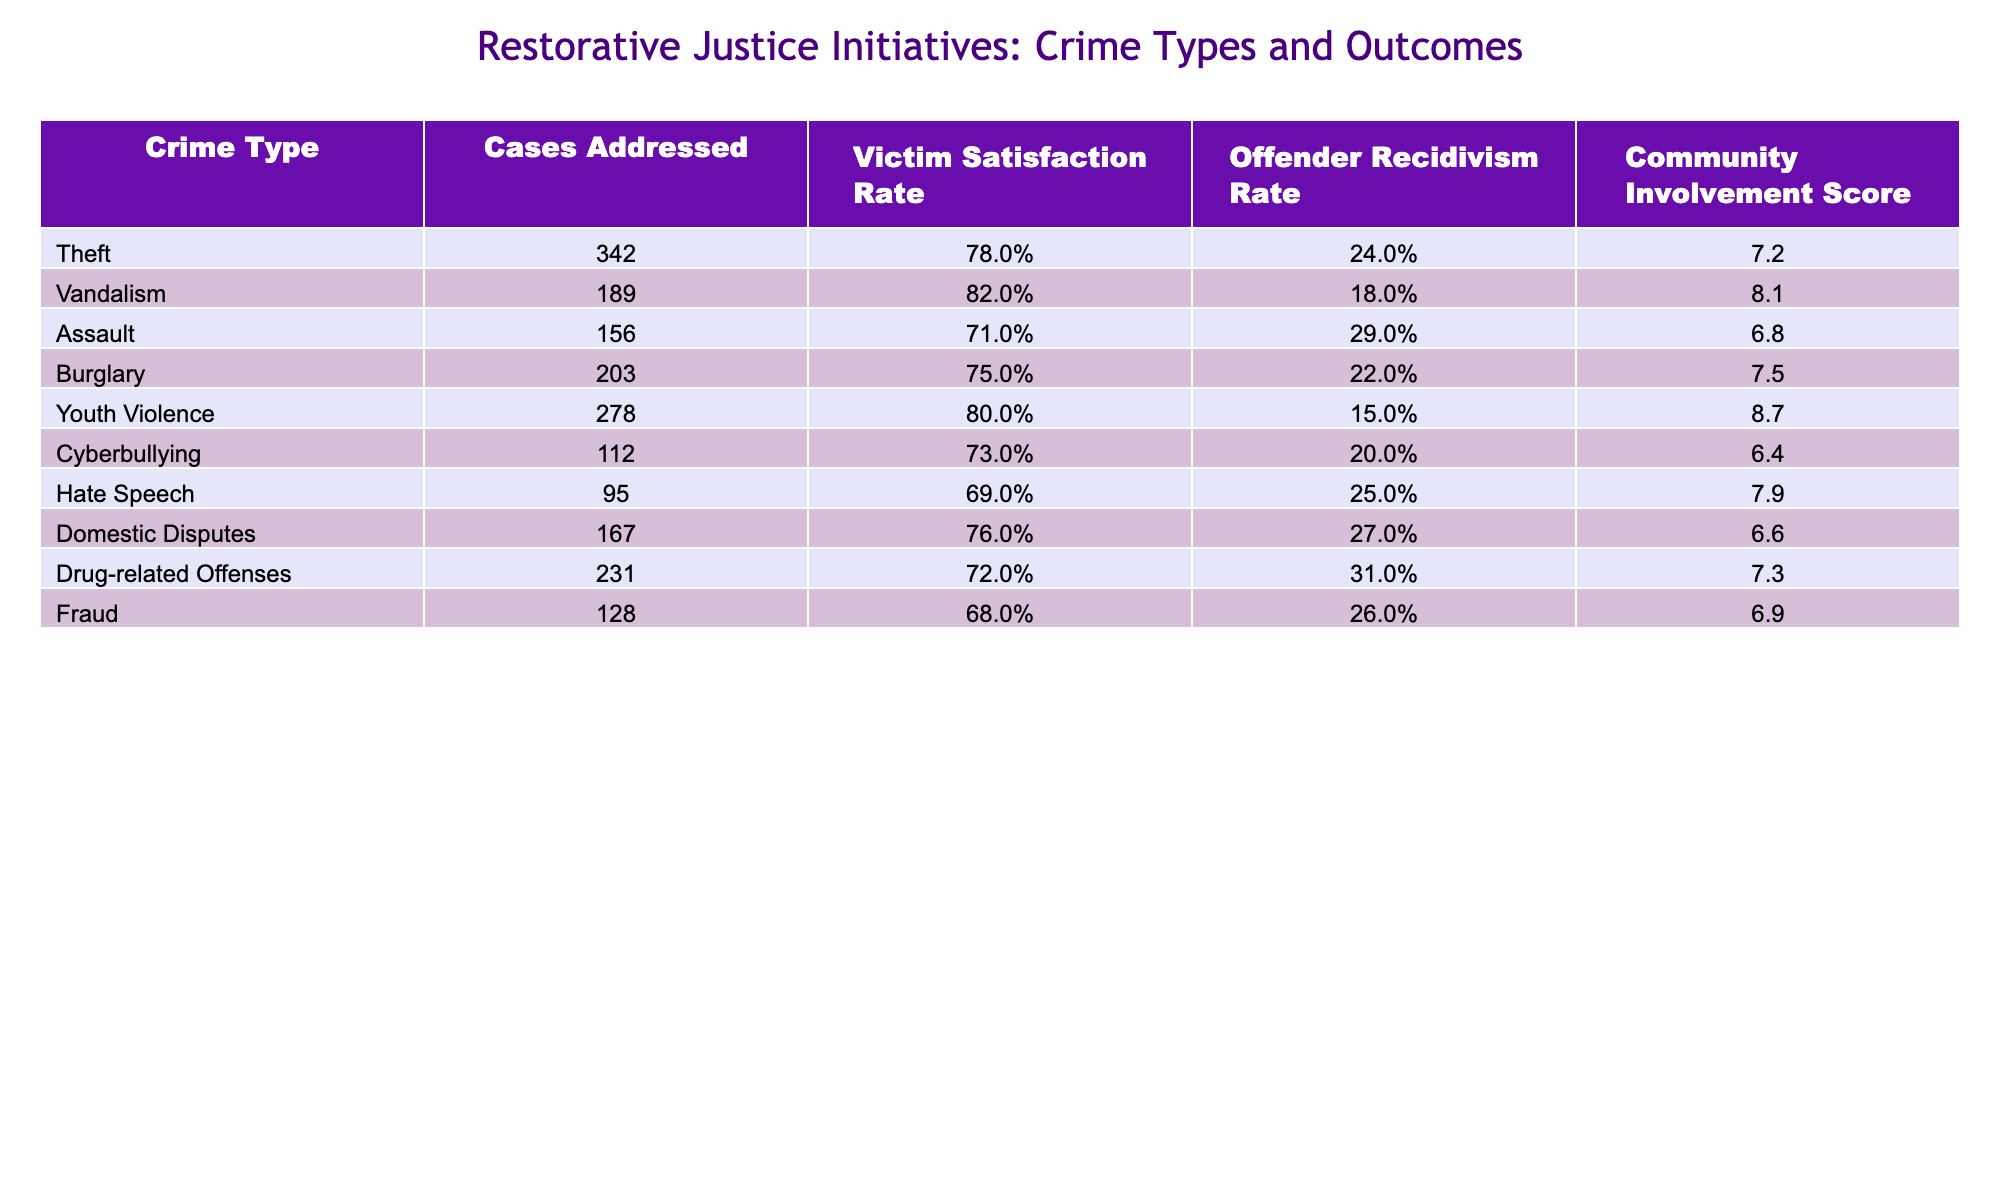What is the victim satisfaction rate for theft? In the table, the victim satisfaction rate for theft is listed in the second column. Looking at that row, it shows 78%.
Answer: 78% Which crime type has the highest community involvement score? By examining the community involvement scores in the last column, youth violence has the highest score of 8.7.
Answer: 8.7 What is the average offender recidivism rate for the crimes listed? To find the average offender recidivism rate, first, convert the percentages for each crime type: (24 + 18 + 29 + 22 + 15 + 20 + 25 + 27 + 31 + 26) / 10 =  21.7%.
Answer: 21.7% Is the victim satisfaction rate for domestic disputes higher than that for assault? The victim satisfaction rate for domestic disputes is 76%, while for assault, it is 71%. Since 76% is greater than 71%, the answer is yes.
Answer: Yes What is the difference in community involvement score between vandalism and drug-related offenses? Vandalism has a community involvement score of 8.1, and drug-related offenses have a score of 7.3. To find the difference, subtract: 8.1 - 7.3 = 0.8.
Answer: 0.8 Which crime type has the lowest victim satisfaction rate? The victim satisfaction rates are: Theft 78%, Vandalism 82%, Assault 71%, Burglary 75%, Youth Violence 80%, Cyberbullying 73%, Hate Speech 69%, Domestic Disputes 76%, Drug-related Offenses 72%, Fraud 68%. Fraud has the lowest at 68%.
Answer: Fraud What is the sum of cases addressed for assault and hate speech? The cases for assault are 156 and for hate speech are 95. Adding them gives: 156 + 95 = 251.
Answer: 251 Are there more cases addressed for burglary than for cyberbullying? The table shows that burglary has 203 cases and cyberbullying has 112 cases. Since 203 is greater than 112, the answer is yes.
Answer: Yes What is the median victim satisfaction rate among the listed crime types? First, list the satisfaction rates in order: 68%, 69%, 71%, 72%, 73%, 75%, 76%, 78%, 80%, 82%. Since there are 10 values, the median will be the average of the 5th and 6th values: (73 + 75) / 2 = 74%.
Answer: 74% How does the offender recidivism rate for youth violence compare to that for hate speech? The offender recidivism rate for youth violence is 15%, and for hate speech, it is 25%. Since 15% is less than 25%, youth violence has a lower rate.
Answer: Lower What combination of crime types leads to the highest total number of cases based on the table? By adding cases addressed, youth violence (278) and theft (342) yield the highest total of 620 (278 + 342).
Answer: 620 